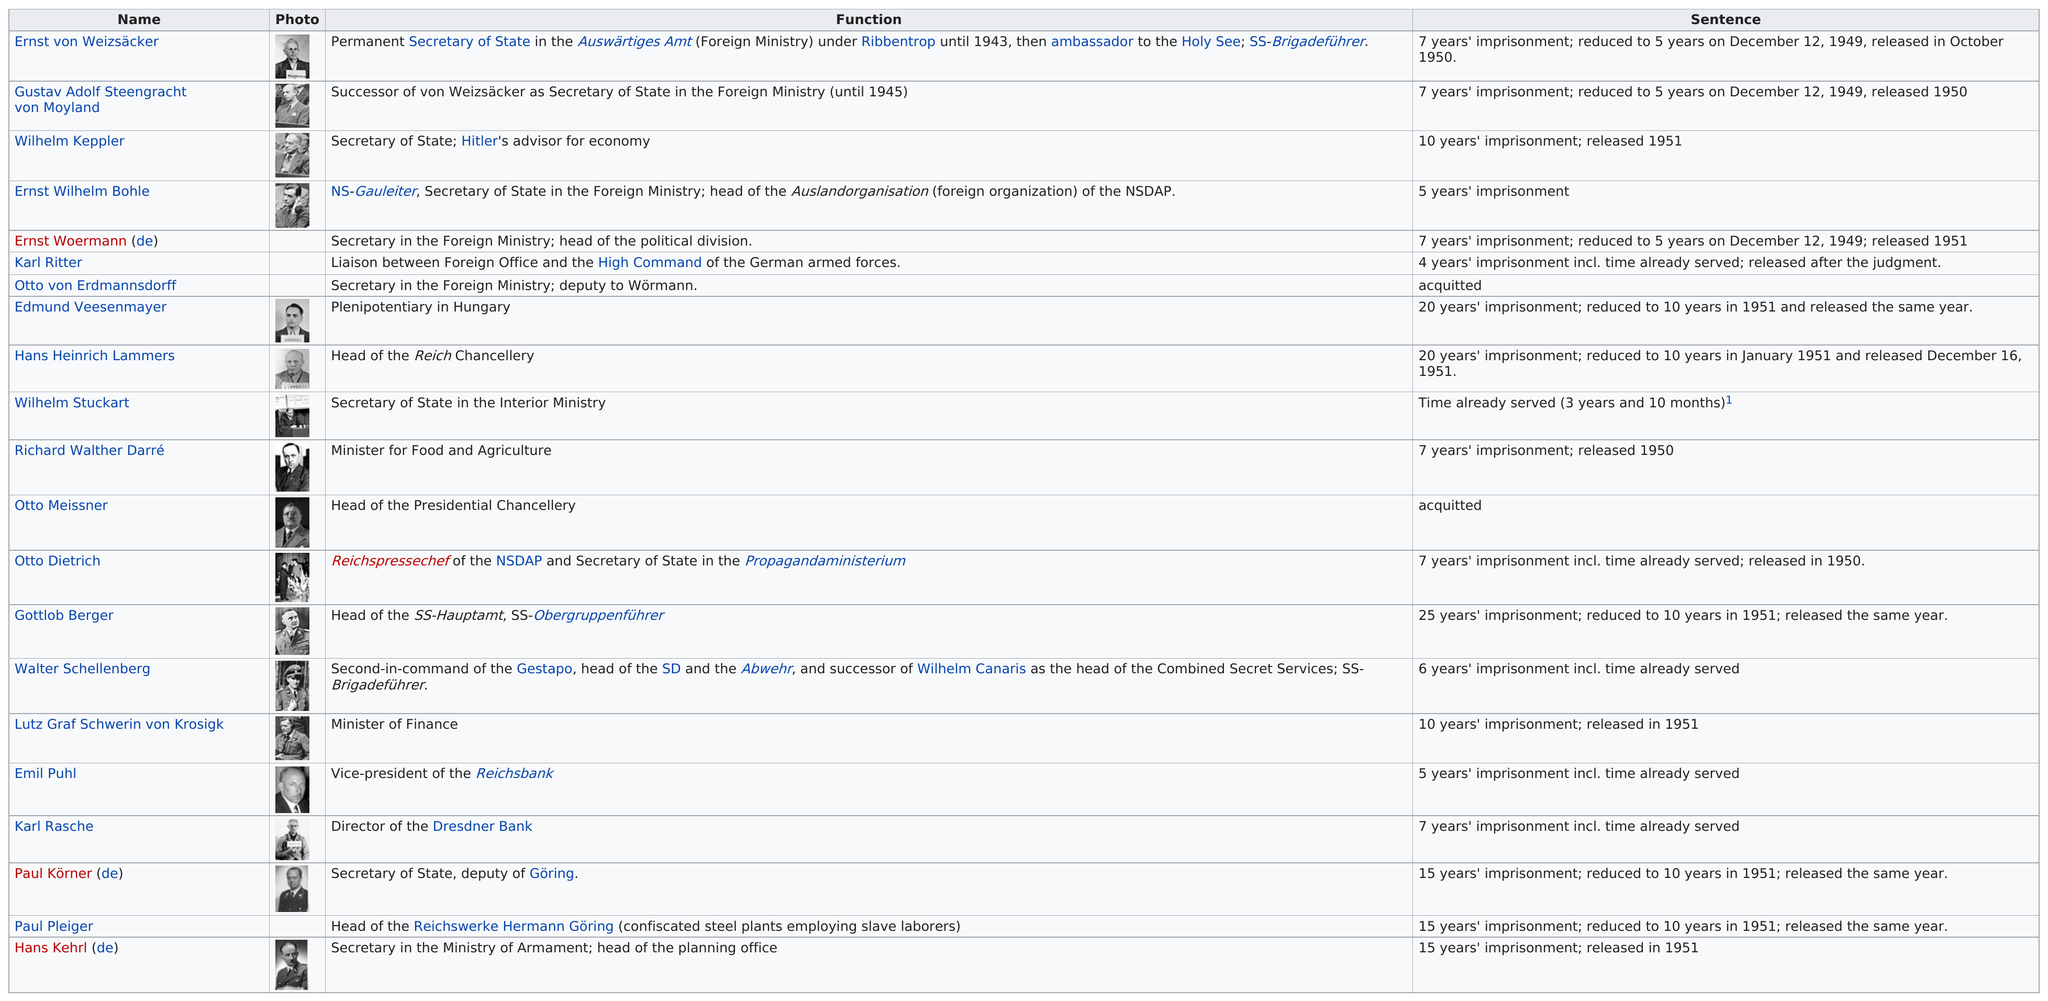Mention a couple of crucial points in this snapshot. Of the defendants who were acquitted, if any, 2 were acquitted. Walter Schellenberg, a defendant, was the second-in-command of the Gestapo. 